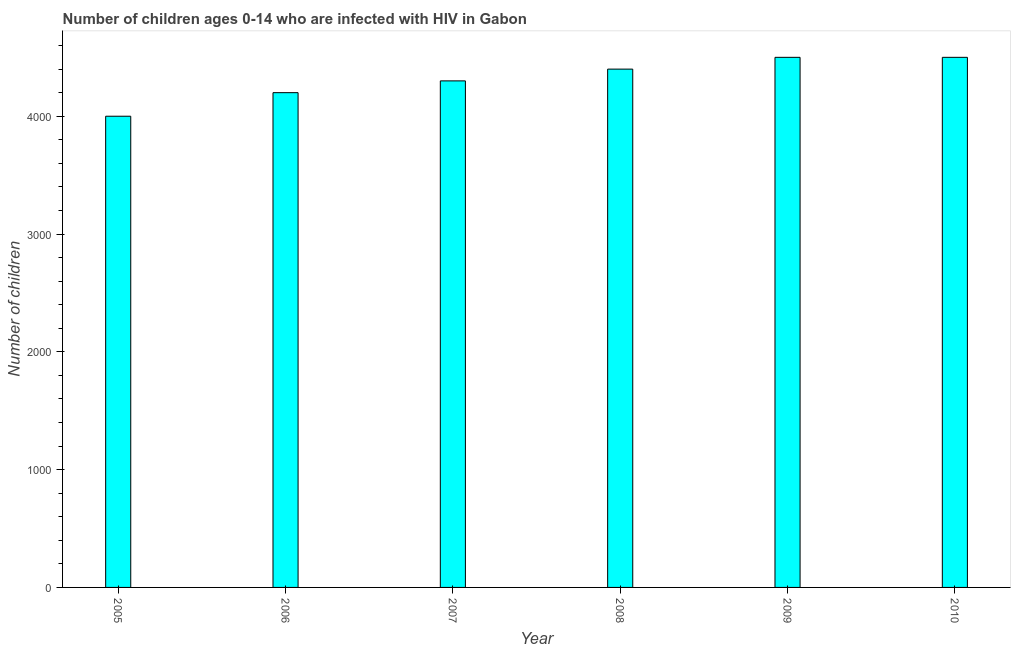Does the graph contain any zero values?
Keep it short and to the point. No. Does the graph contain grids?
Ensure brevity in your answer.  No. What is the title of the graph?
Offer a very short reply. Number of children ages 0-14 who are infected with HIV in Gabon. What is the label or title of the X-axis?
Ensure brevity in your answer.  Year. What is the label or title of the Y-axis?
Provide a succinct answer. Number of children. What is the number of children living with hiv in 2006?
Your response must be concise. 4200. Across all years, what is the maximum number of children living with hiv?
Offer a terse response. 4500. Across all years, what is the minimum number of children living with hiv?
Your response must be concise. 4000. In which year was the number of children living with hiv maximum?
Offer a terse response. 2009. What is the sum of the number of children living with hiv?
Give a very brief answer. 2.59e+04. What is the difference between the number of children living with hiv in 2007 and 2009?
Offer a very short reply. -200. What is the average number of children living with hiv per year?
Keep it short and to the point. 4316. What is the median number of children living with hiv?
Offer a terse response. 4350. What is the ratio of the number of children living with hiv in 2006 to that in 2009?
Offer a very short reply. 0.93. Is the difference between the number of children living with hiv in 2008 and 2009 greater than the difference between any two years?
Ensure brevity in your answer.  No. Is the sum of the number of children living with hiv in 2006 and 2010 greater than the maximum number of children living with hiv across all years?
Your answer should be compact. Yes. In how many years, is the number of children living with hiv greater than the average number of children living with hiv taken over all years?
Offer a very short reply. 3. How many bars are there?
Your response must be concise. 6. How many years are there in the graph?
Offer a very short reply. 6. Are the values on the major ticks of Y-axis written in scientific E-notation?
Offer a very short reply. No. What is the Number of children in 2005?
Your answer should be very brief. 4000. What is the Number of children of 2006?
Ensure brevity in your answer.  4200. What is the Number of children of 2007?
Keep it short and to the point. 4300. What is the Number of children of 2008?
Make the answer very short. 4400. What is the Number of children of 2009?
Give a very brief answer. 4500. What is the Number of children of 2010?
Your answer should be compact. 4500. What is the difference between the Number of children in 2005 and 2006?
Your response must be concise. -200. What is the difference between the Number of children in 2005 and 2007?
Offer a terse response. -300. What is the difference between the Number of children in 2005 and 2008?
Your answer should be compact. -400. What is the difference between the Number of children in 2005 and 2009?
Make the answer very short. -500. What is the difference between the Number of children in 2005 and 2010?
Offer a terse response. -500. What is the difference between the Number of children in 2006 and 2007?
Offer a terse response. -100. What is the difference between the Number of children in 2006 and 2008?
Your answer should be compact. -200. What is the difference between the Number of children in 2006 and 2009?
Provide a succinct answer. -300. What is the difference between the Number of children in 2006 and 2010?
Ensure brevity in your answer.  -300. What is the difference between the Number of children in 2007 and 2008?
Keep it short and to the point. -100. What is the difference between the Number of children in 2007 and 2009?
Give a very brief answer. -200. What is the difference between the Number of children in 2007 and 2010?
Your response must be concise. -200. What is the difference between the Number of children in 2008 and 2009?
Provide a succinct answer. -100. What is the difference between the Number of children in 2008 and 2010?
Your answer should be very brief. -100. What is the difference between the Number of children in 2009 and 2010?
Your answer should be very brief. 0. What is the ratio of the Number of children in 2005 to that in 2008?
Offer a very short reply. 0.91. What is the ratio of the Number of children in 2005 to that in 2009?
Keep it short and to the point. 0.89. What is the ratio of the Number of children in 2005 to that in 2010?
Provide a short and direct response. 0.89. What is the ratio of the Number of children in 2006 to that in 2008?
Offer a very short reply. 0.95. What is the ratio of the Number of children in 2006 to that in 2009?
Your response must be concise. 0.93. What is the ratio of the Number of children in 2006 to that in 2010?
Your response must be concise. 0.93. What is the ratio of the Number of children in 2007 to that in 2008?
Ensure brevity in your answer.  0.98. What is the ratio of the Number of children in 2007 to that in 2009?
Ensure brevity in your answer.  0.96. What is the ratio of the Number of children in 2007 to that in 2010?
Your answer should be very brief. 0.96. 